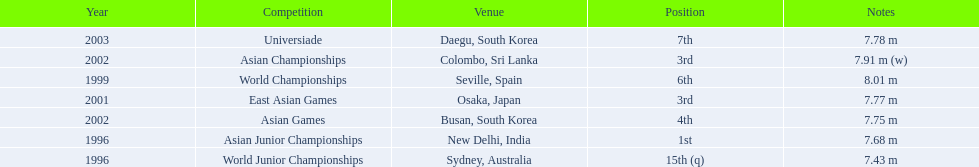Which year was his best jump? 1999. 